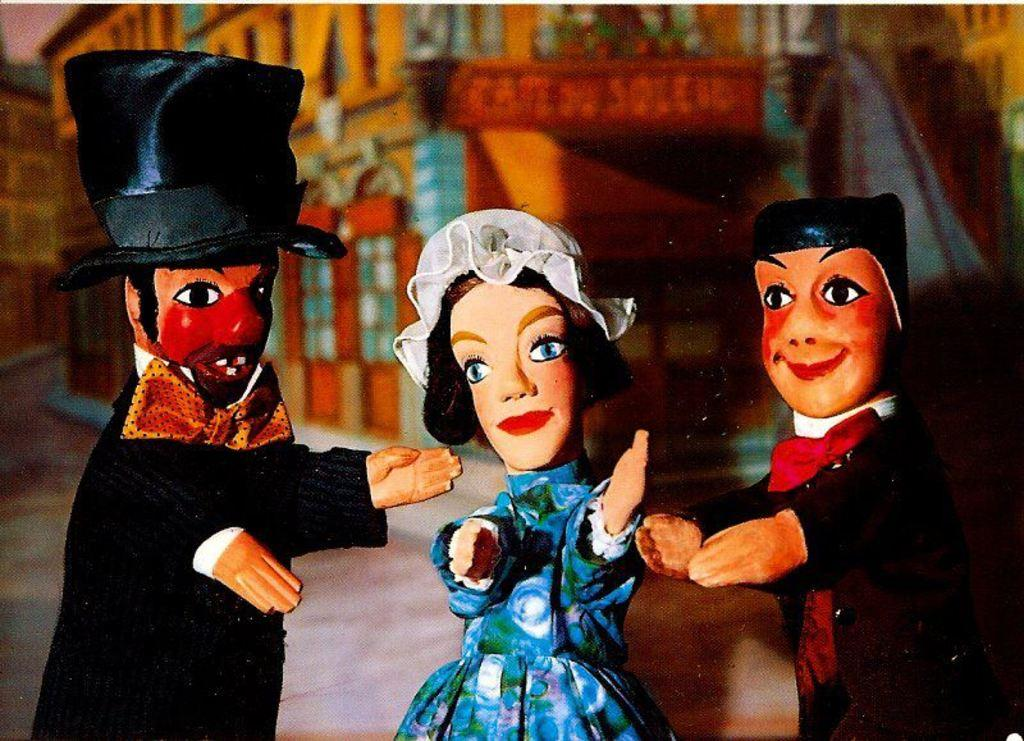What objects can be seen in the image? There are toys in the image. What type of background is present in the image? There is a house background in the image. How does the kite contribute to the digestion process in the image? There is no kite present in the image, so it cannot contribute to any digestion process. 